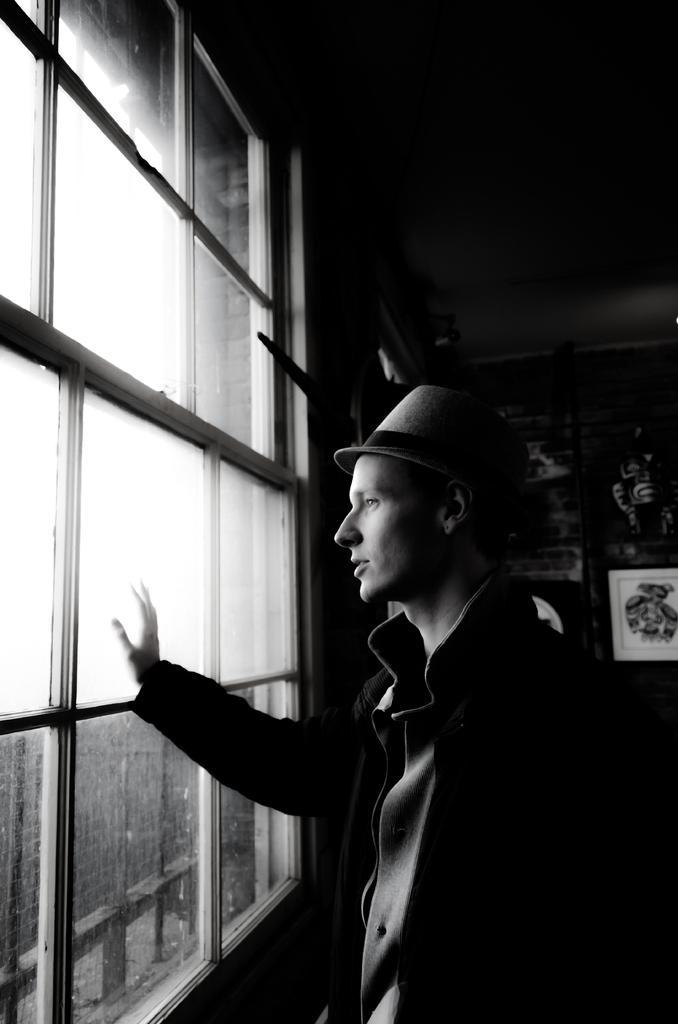In one or two sentences, can you explain what this image depicts? In this image we can see a man standing beside a window. We can also see some frames on a wall. On the left side we can see some buildings and the sky. 